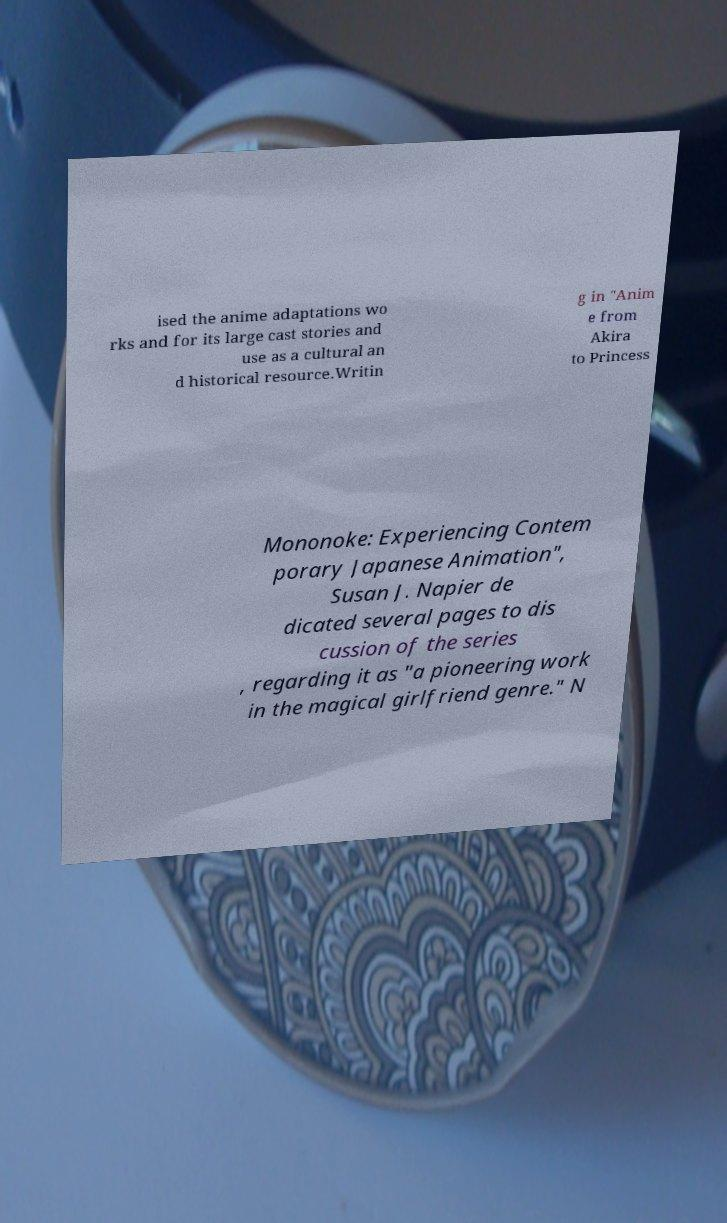Could you extract and type out the text from this image? ised the anime adaptations wo rks and for its large cast stories and use as a cultural an d historical resource.Writin g in "Anim e from Akira to Princess Mononoke: Experiencing Contem porary Japanese Animation", Susan J. Napier de dicated several pages to dis cussion of the series , regarding it as "a pioneering work in the magical girlfriend genre." N 